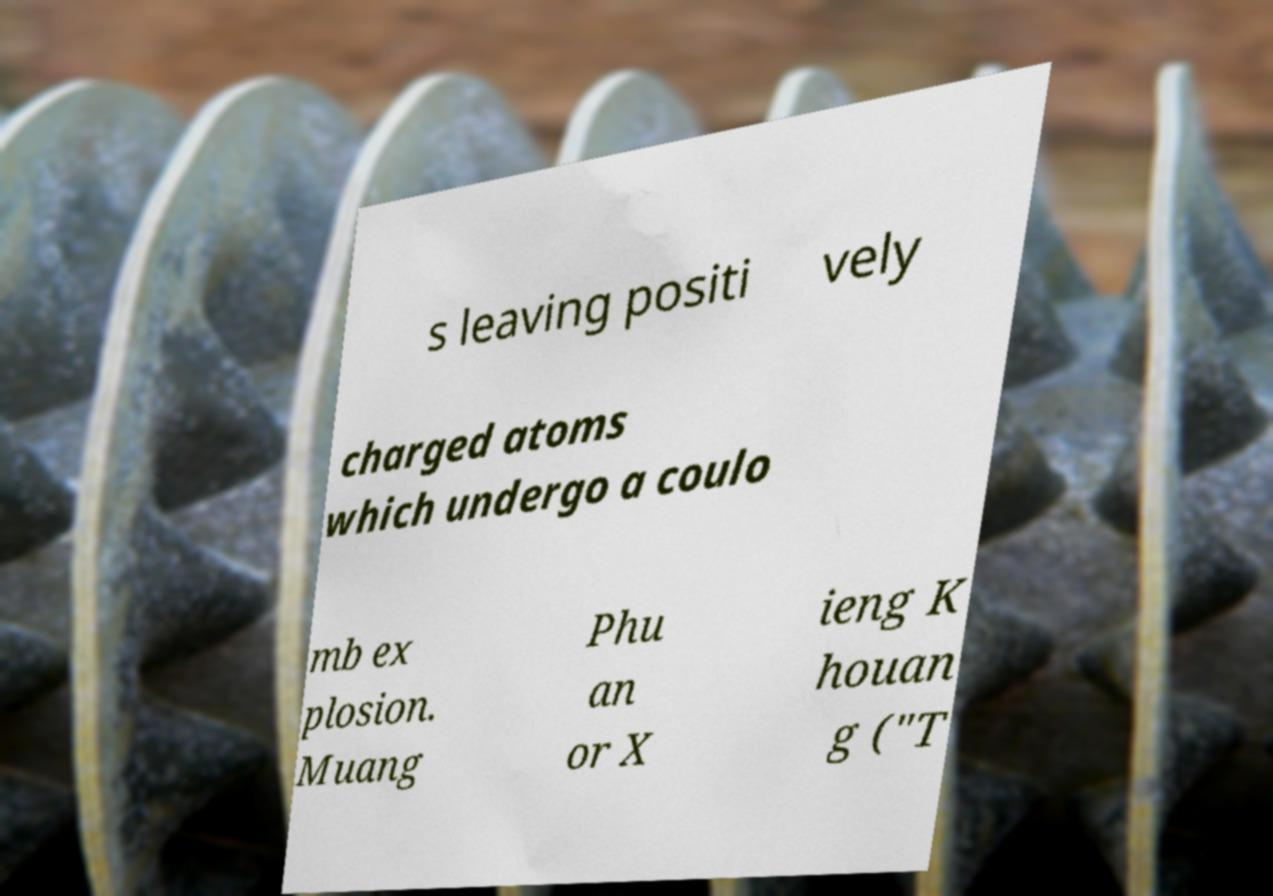Could you assist in decoding the text presented in this image and type it out clearly? s leaving positi vely charged atoms which undergo a coulo mb ex plosion. Muang Phu an or X ieng K houan g ("T 